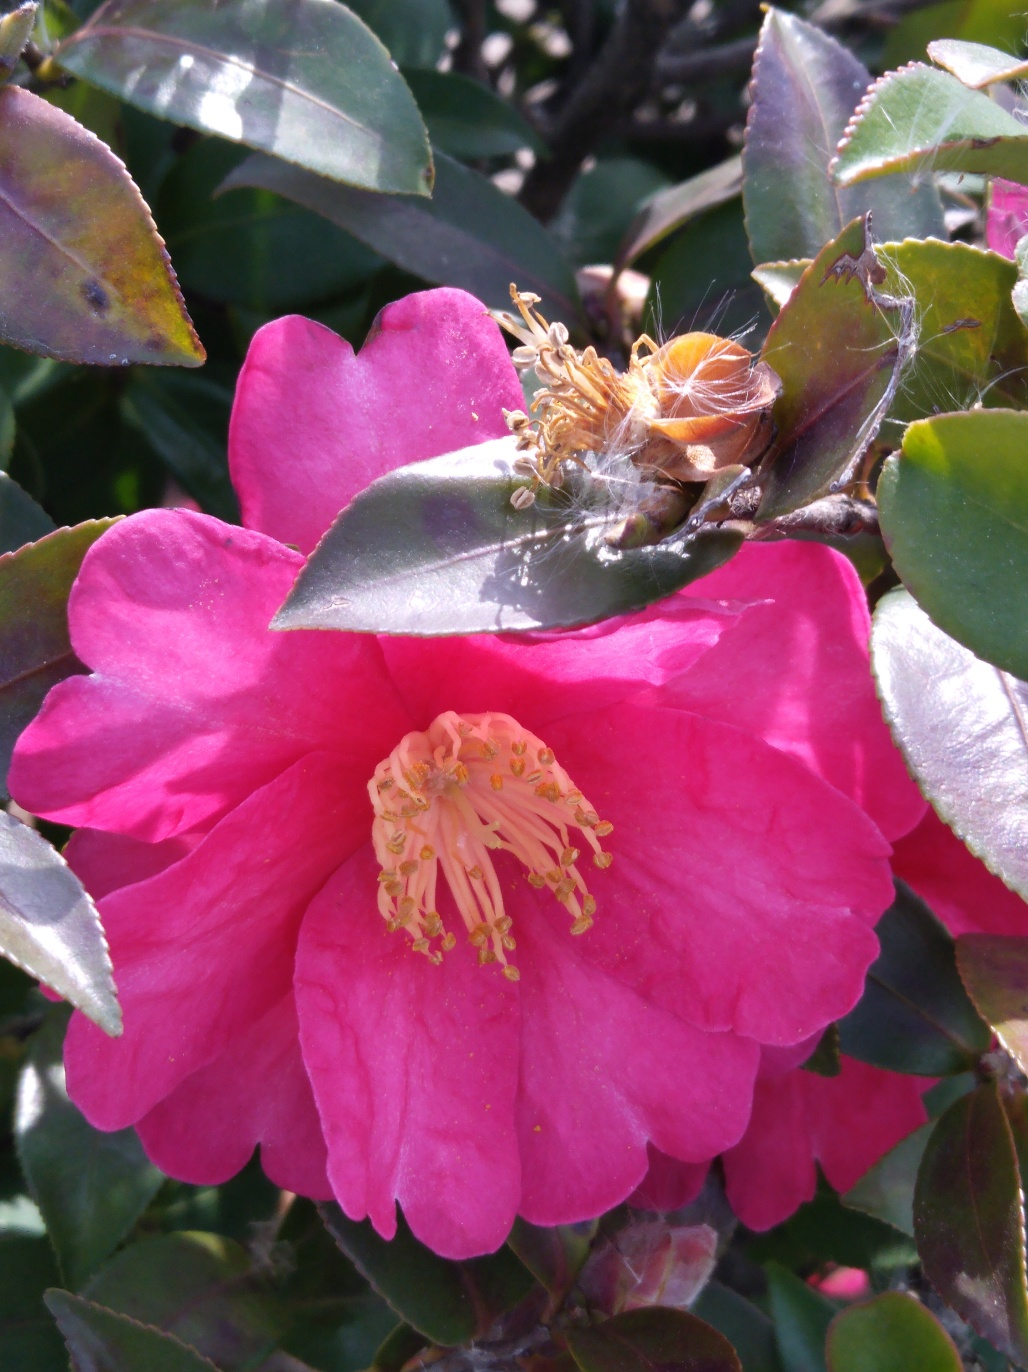What type of flower is shown in the image? This appears to be a Camellia flower, which is known for its vibrant colors and lush petals. 